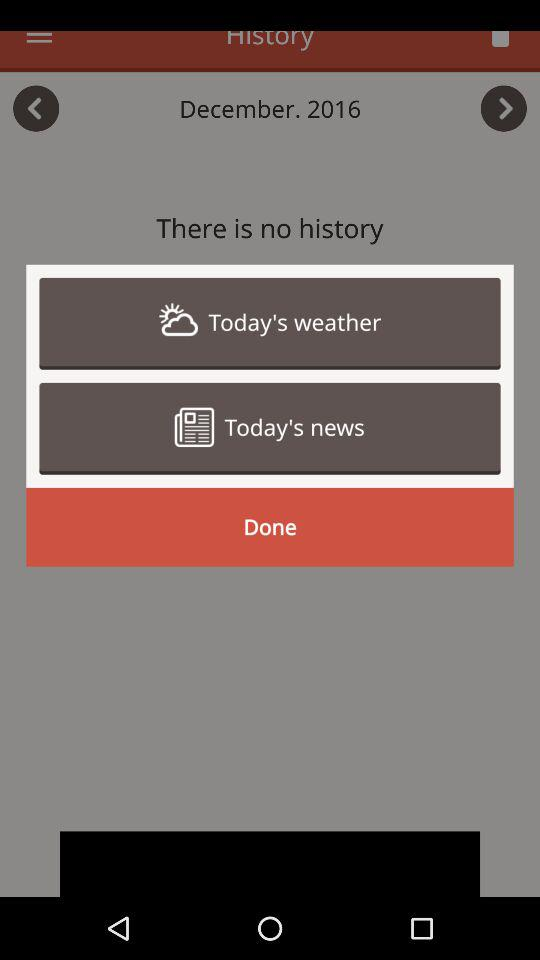Is there any history? There is no history. 